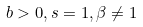Convert formula to latex. <formula><loc_0><loc_0><loc_500><loc_500>b > 0 , s = 1 , \beta \ne 1</formula> 